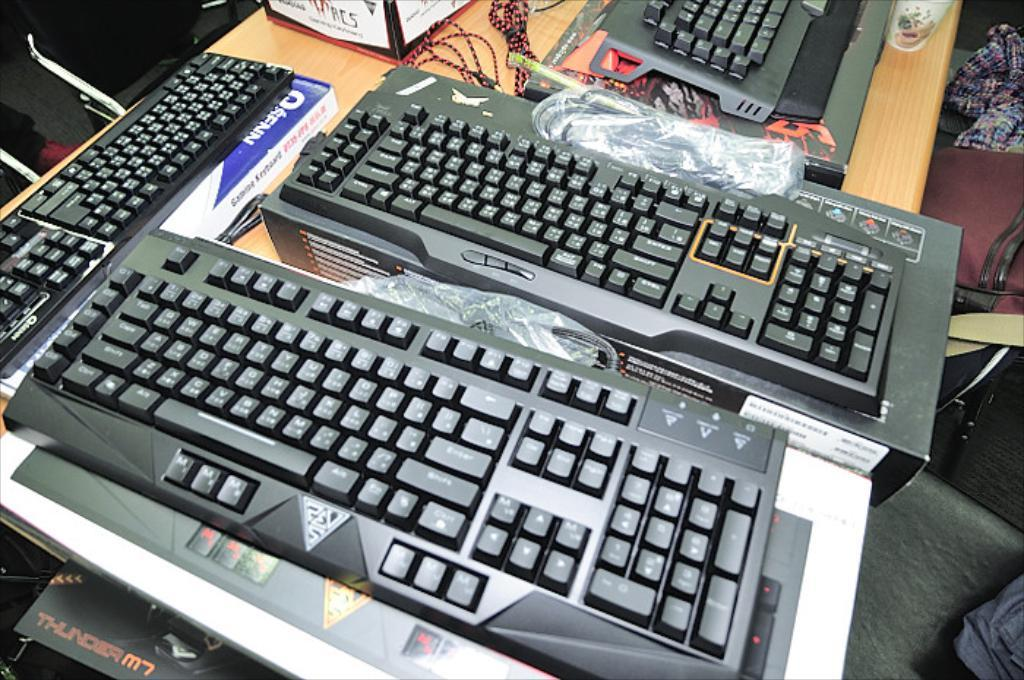<image>
Describe the image concisely. The word thunder can be seen below a keyboard on a table. 